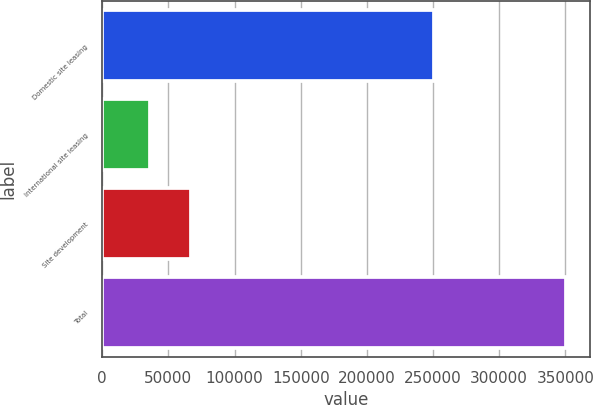Convert chart. <chart><loc_0><loc_0><loc_500><loc_500><bar_chart><fcel>Domestic site leasing<fcel>International site leasing<fcel>Site development<fcel>Total<nl><fcel>250962<fcel>35957<fcel>67439.5<fcel>350782<nl></chart> 